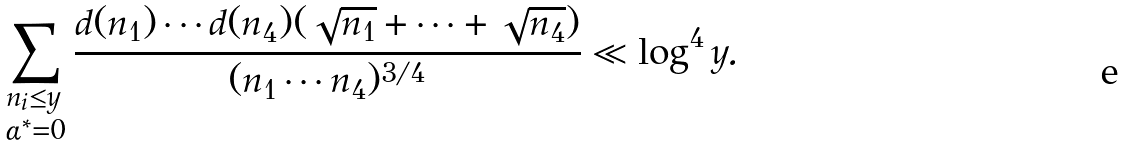Convert formula to latex. <formula><loc_0><loc_0><loc_500><loc_500>\sum _ { \begin{subarray} { c } n _ { i } \leq y \\ \alpha ^ { * } = 0 \end{subarray} } \frac { d ( n _ { 1 } ) \cdots d ( n _ { 4 } ) ( \sqrt { n _ { 1 } } + \cdots + \sqrt { n _ { 4 } } ) } { ( n _ { 1 } \cdots n _ { 4 } ) ^ { 3 / 4 } } \ll \log ^ { 4 } y .</formula> 